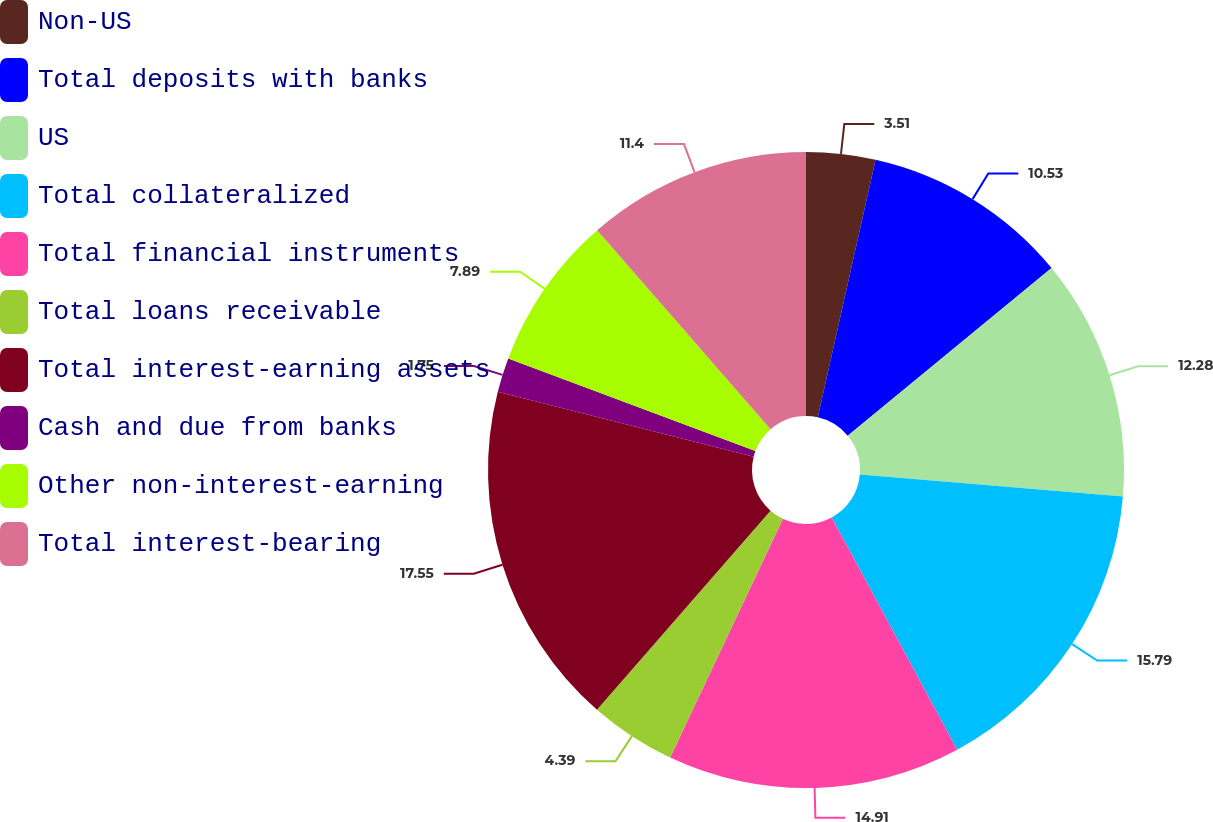Convert chart to OTSL. <chart><loc_0><loc_0><loc_500><loc_500><pie_chart><fcel>Non-US<fcel>Total deposits with banks<fcel>US<fcel>Total collateralized<fcel>Total financial instruments<fcel>Total loans receivable<fcel>Total interest-earning assets<fcel>Cash and due from banks<fcel>Other non-interest-earning<fcel>Total interest-bearing<nl><fcel>3.51%<fcel>10.53%<fcel>12.28%<fcel>15.79%<fcel>14.91%<fcel>4.39%<fcel>17.54%<fcel>1.75%<fcel>7.89%<fcel>11.4%<nl></chart> 